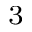Convert formula to latex. <formula><loc_0><loc_0><loc_500><loc_500>^ { 3 }</formula> 